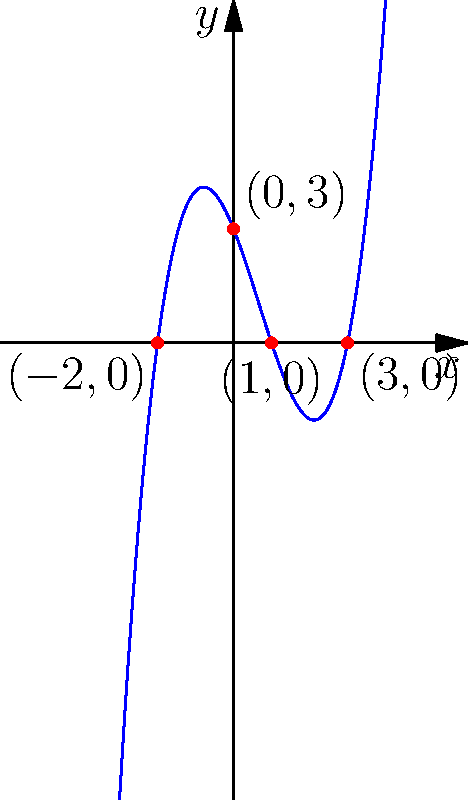As a Korean immigrant who has navigated complex immigration procedures, you understand the importance of attention to detail. Imagine this polynomial graph represents the fluctuations in visa processing times over the past few years. Identify the y-intercept and x-intercepts of this polynomial function, which could represent critical points in the immigration timeline. Let's approach this step-by-step:

1) Y-intercept:
   The y-intercept is the point where the graph crosses the y-axis. This occurs when x = 0.
   From the graph, we can see that the curve intersects the y-axis at (0,3).
   Therefore, the y-intercept is (0,3).

2) X-intercepts:
   X-intercepts are the points where the graph crosses the x-axis. These occur when y = 0.
   From the graph, we can identify three x-intercepts:
   a) (-2,0)
   b) (1,0)
   c) (3,0)

3) To summarize:
   Y-intercept: (0,3)
   X-intercepts: -2, 1, and 3

In the context of immigration, these points could represent:
- Y-intercept (0,3): The initial processing time (3 units) at the start of the observation period.
- X-intercepts: Times when the processing time was zero (possibly due to policy changes or increased efficiency).
Answer: Y-intercept: (0,3); X-intercepts: -2, 1, 3 